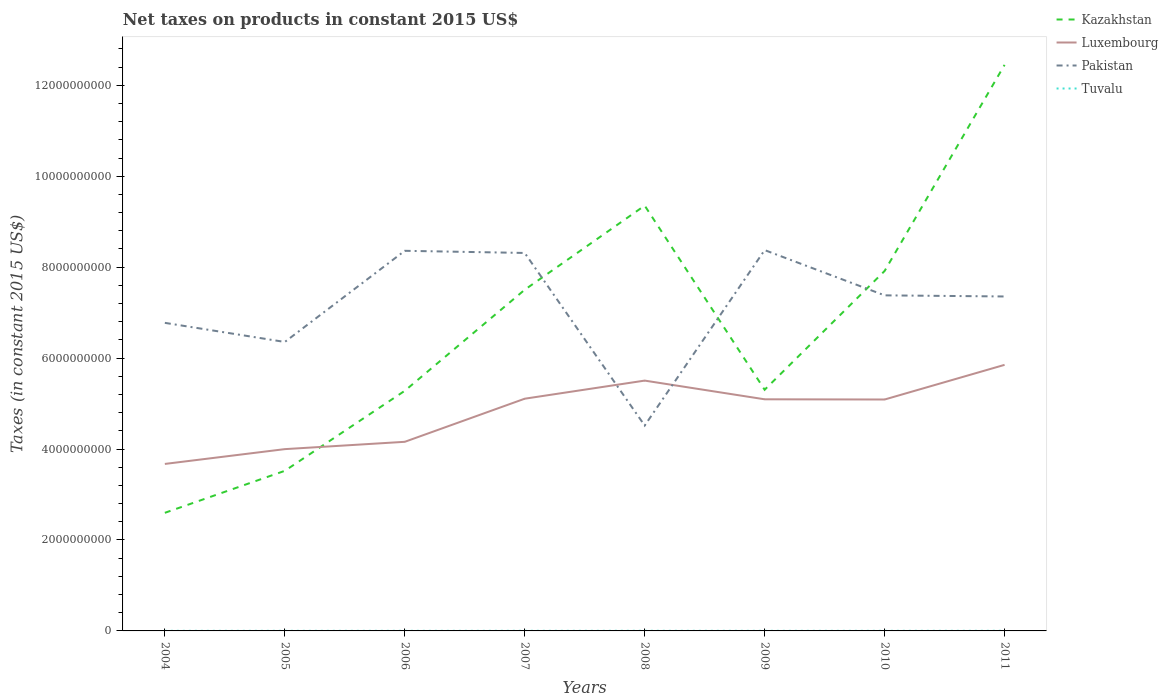Across all years, what is the maximum net taxes on products in Tuvalu?
Give a very brief answer. 1.97e+06. What is the total net taxes on products in Kazakhstan in the graph?
Offer a very short reply. -2.31e+07. What is the difference between the highest and the second highest net taxes on products in Kazakhstan?
Your answer should be very brief. 9.85e+09. What is the difference between the highest and the lowest net taxes on products in Kazakhstan?
Offer a very short reply. 4. What is the difference between two consecutive major ticks on the Y-axis?
Offer a very short reply. 2.00e+09. Does the graph contain any zero values?
Your answer should be compact. No. Does the graph contain grids?
Make the answer very short. No. Where does the legend appear in the graph?
Make the answer very short. Top right. How many legend labels are there?
Give a very brief answer. 4. What is the title of the graph?
Offer a very short reply. Net taxes on products in constant 2015 US$. What is the label or title of the Y-axis?
Your response must be concise. Taxes (in constant 2015 US$). What is the Taxes (in constant 2015 US$) of Kazakhstan in 2004?
Offer a very short reply. 2.60e+09. What is the Taxes (in constant 2015 US$) in Luxembourg in 2004?
Your answer should be very brief. 3.67e+09. What is the Taxes (in constant 2015 US$) of Pakistan in 2004?
Provide a succinct answer. 6.78e+09. What is the Taxes (in constant 2015 US$) in Tuvalu in 2004?
Ensure brevity in your answer.  2.11e+06. What is the Taxes (in constant 2015 US$) of Kazakhstan in 2005?
Keep it short and to the point. 3.52e+09. What is the Taxes (in constant 2015 US$) of Luxembourg in 2005?
Your answer should be compact. 4.00e+09. What is the Taxes (in constant 2015 US$) of Pakistan in 2005?
Make the answer very short. 6.35e+09. What is the Taxes (in constant 2015 US$) in Tuvalu in 2005?
Offer a very short reply. 2.13e+06. What is the Taxes (in constant 2015 US$) of Kazakhstan in 2006?
Keep it short and to the point. 5.28e+09. What is the Taxes (in constant 2015 US$) in Luxembourg in 2006?
Ensure brevity in your answer.  4.16e+09. What is the Taxes (in constant 2015 US$) in Pakistan in 2006?
Give a very brief answer. 8.36e+09. What is the Taxes (in constant 2015 US$) of Tuvalu in 2006?
Provide a short and direct response. 1.97e+06. What is the Taxes (in constant 2015 US$) in Kazakhstan in 2007?
Give a very brief answer. 7.50e+09. What is the Taxes (in constant 2015 US$) of Luxembourg in 2007?
Your answer should be compact. 5.11e+09. What is the Taxes (in constant 2015 US$) in Pakistan in 2007?
Your answer should be compact. 8.31e+09. What is the Taxes (in constant 2015 US$) of Tuvalu in 2007?
Offer a terse response. 2.33e+06. What is the Taxes (in constant 2015 US$) of Kazakhstan in 2008?
Your answer should be very brief. 9.35e+09. What is the Taxes (in constant 2015 US$) of Luxembourg in 2008?
Ensure brevity in your answer.  5.51e+09. What is the Taxes (in constant 2015 US$) in Pakistan in 2008?
Ensure brevity in your answer.  4.52e+09. What is the Taxes (in constant 2015 US$) in Tuvalu in 2008?
Offer a very short reply. 2.66e+06. What is the Taxes (in constant 2015 US$) of Kazakhstan in 2009?
Keep it short and to the point. 5.30e+09. What is the Taxes (in constant 2015 US$) in Luxembourg in 2009?
Your answer should be very brief. 5.09e+09. What is the Taxes (in constant 2015 US$) in Pakistan in 2009?
Provide a succinct answer. 8.38e+09. What is the Taxes (in constant 2015 US$) of Tuvalu in 2009?
Offer a very short reply. 2.12e+06. What is the Taxes (in constant 2015 US$) of Kazakhstan in 2010?
Your answer should be very brief. 7.92e+09. What is the Taxes (in constant 2015 US$) in Luxembourg in 2010?
Make the answer very short. 5.09e+09. What is the Taxes (in constant 2015 US$) of Pakistan in 2010?
Your answer should be compact. 7.38e+09. What is the Taxes (in constant 2015 US$) of Tuvalu in 2010?
Your answer should be very brief. 2.17e+06. What is the Taxes (in constant 2015 US$) in Kazakhstan in 2011?
Your response must be concise. 1.24e+1. What is the Taxes (in constant 2015 US$) in Luxembourg in 2011?
Your response must be concise. 5.85e+09. What is the Taxes (in constant 2015 US$) of Pakistan in 2011?
Your response must be concise. 7.36e+09. What is the Taxes (in constant 2015 US$) of Tuvalu in 2011?
Your answer should be very brief. 2.62e+06. Across all years, what is the maximum Taxes (in constant 2015 US$) in Kazakhstan?
Your response must be concise. 1.24e+1. Across all years, what is the maximum Taxes (in constant 2015 US$) of Luxembourg?
Your answer should be compact. 5.85e+09. Across all years, what is the maximum Taxes (in constant 2015 US$) in Pakistan?
Provide a succinct answer. 8.38e+09. Across all years, what is the maximum Taxes (in constant 2015 US$) in Tuvalu?
Offer a terse response. 2.66e+06. Across all years, what is the minimum Taxes (in constant 2015 US$) of Kazakhstan?
Make the answer very short. 2.60e+09. Across all years, what is the minimum Taxes (in constant 2015 US$) of Luxembourg?
Your answer should be compact. 3.67e+09. Across all years, what is the minimum Taxes (in constant 2015 US$) of Pakistan?
Provide a short and direct response. 4.52e+09. Across all years, what is the minimum Taxes (in constant 2015 US$) of Tuvalu?
Your response must be concise. 1.97e+06. What is the total Taxes (in constant 2015 US$) in Kazakhstan in the graph?
Keep it short and to the point. 5.39e+1. What is the total Taxes (in constant 2015 US$) of Luxembourg in the graph?
Keep it short and to the point. 3.85e+1. What is the total Taxes (in constant 2015 US$) in Pakistan in the graph?
Offer a very short reply. 5.74e+1. What is the total Taxes (in constant 2015 US$) of Tuvalu in the graph?
Provide a succinct answer. 1.81e+07. What is the difference between the Taxes (in constant 2015 US$) of Kazakhstan in 2004 and that in 2005?
Offer a very short reply. -9.24e+08. What is the difference between the Taxes (in constant 2015 US$) in Luxembourg in 2004 and that in 2005?
Your response must be concise. -3.26e+08. What is the difference between the Taxes (in constant 2015 US$) of Pakistan in 2004 and that in 2005?
Offer a terse response. 4.20e+08. What is the difference between the Taxes (in constant 2015 US$) of Tuvalu in 2004 and that in 2005?
Your response must be concise. -1.47e+04. What is the difference between the Taxes (in constant 2015 US$) of Kazakhstan in 2004 and that in 2006?
Ensure brevity in your answer.  -2.68e+09. What is the difference between the Taxes (in constant 2015 US$) in Luxembourg in 2004 and that in 2006?
Ensure brevity in your answer.  -4.86e+08. What is the difference between the Taxes (in constant 2015 US$) in Pakistan in 2004 and that in 2006?
Provide a succinct answer. -1.58e+09. What is the difference between the Taxes (in constant 2015 US$) of Tuvalu in 2004 and that in 2006?
Give a very brief answer. 1.41e+05. What is the difference between the Taxes (in constant 2015 US$) of Kazakhstan in 2004 and that in 2007?
Offer a very short reply. -4.91e+09. What is the difference between the Taxes (in constant 2015 US$) in Luxembourg in 2004 and that in 2007?
Keep it short and to the point. -1.43e+09. What is the difference between the Taxes (in constant 2015 US$) of Pakistan in 2004 and that in 2007?
Offer a terse response. -1.54e+09. What is the difference between the Taxes (in constant 2015 US$) in Tuvalu in 2004 and that in 2007?
Provide a succinct answer. -2.15e+05. What is the difference between the Taxes (in constant 2015 US$) of Kazakhstan in 2004 and that in 2008?
Provide a short and direct response. -6.76e+09. What is the difference between the Taxes (in constant 2015 US$) in Luxembourg in 2004 and that in 2008?
Provide a short and direct response. -1.83e+09. What is the difference between the Taxes (in constant 2015 US$) in Pakistan in 2004 and that in 2008?
Your response must be concise. 2.26e+09. What is the difference between the Taxes (in constant 2015 US$) of Tuvalu in 2004 and that in 2008?
Your response must be concise. -5.41e+05. What is the difference between the Taxes (in constant 2015 US$) of Kazakhstan in 2004 and that in 2009?
Make the answer very short. -2.71e+09. What is the difference between the Taxes (in constant 2015 US$) in Luxembourg in 2004 and that in 2009?
Ensure brevity in your answer.  -1.42e+09. What is the difference between the Taxes (in constant 2015 US$) in Pakistan in 2004 and that in 2009?
Ensure brevity in your answer.  -1.60e+09. What is the difference between the Taxes (in constant 2015 US$) in Tuvalu in 2004 and that in 2009?
Offer a very short reply. -3246.09. What is the difference between the Taxes (in constant 2015 US$) in Kazakhstan in 2004 and that in 2010?
Ensure brevity in your answer.  -5.32e+09. What is the difference between the Taxes (in constant 2015 US$) of Luxembourg in 2004 and that in 2010?
Offer a terse response. -1.42e+09. What is the difference between the Taxes (in constant 2015 US$) of Pakistan in 2004 and that in 2010?
Your answer should be compact. -6.05e+08. What is the difference between the Taxes (in constant 2015 US$) of Tuvalu in 2004 and that in 2010?
Provide a succinct answer. -5.14e+04. What is the difference between the Taxes (in constant 2015 US$) of Kazakhstan in 2004 and that in 2011?
Ensure brevity in your answer.  -9.85e+09. What is the difference between the Taxes (in constant 2015 US$) in Luxembourg in 2004 and that in 2011?
Your response must be concise. -2.18e+09. What is the difference between the Taxes (in constant 2015 US$) of Pakistan in 2004 and that in 2011?
Provide a succinct answer. -5.80e+08. What is the difference between the Taxes (in constant 2015 US$) in Tuvalu in 2004 and that in 2011?
Your answer should be very brief. -5.08e+05. What is the difference between the Taxes (in constant 2015 US$) in Kazakhstan in 2005 and that in 2006?
Give a very brief answer. -1.76e+09. What is the difference between the Taxes (in constant 2015 US$) in Luxembourg in 2005 and that in 2006?
Give a very brief answer. -1.61e+08. What is the difference between the Taxes (in constant 2015 US$) of Pakistan in 2005 and that in 2006?
Offer a very short reply. -2.00e+09. What is the difference between the Taxes (in constant 2015 US$) of Tuvalu in 2005 and that in 2006?
Give a very brief answer. 1.56e+05. What is the difference between the Taxes (in constant 2015 US$) in Kazakhstan in 2005 and that in 2007?
Offer a terse response. -3.98e+09. What is the difference between the Taxes (in constant 2015 US$) of Luxembourg in 2005 and that in 2007?
Provide a short and direct response. -1.11e+09. What is the difference between the Taxes (in constant 2015 US$) in Pakistan in 2005 and that in 2007?
Provide a succinct answer. -1.96e+09. What is the difference between the Taxes (in constant 2015 US$) in Tuvalu in 2005 and that in 2007?
Your answer should be very brief. -2.01e+05. What is the difference between the Taxes (in constant 2015 US$) in Kazakhstan in 2005 and that in 2008?
Keep it short and to the point. -5.83e+09. What is the difference between the Taxes (in constant 2015 US$) of Luxembourg in 2005 and that in 2008?
Offer a very short reply. -1.51e+09. What is the difference between the Taxes (in constant 2015 US$) in Pakistan in 2005 and that in 2008?
Your answer should be compact. 1.84e+09. What is the difference between the Taxes (in constant 2015 US$) of Tuvalu in 2005 and that in 2008?
Make the answer very short. -5.27e+05. What is the difference between the Taxes (in constant 2015 US$) in Kazakhstan in 2005 and that in 2009?
Provide a succinct answer. -1.78e+09. What is the difference between the Taxes (in constant 2015 US$) of Luxembourg in 2005 and that in 2009?
Offer a very short reply. -1.10e+09. What is the difference between the Taxes (in constant 2015 US$) of Pakistan in 2005 and that in 2009?
Provide a short and direct response. -2.02e+09. What is the difference between the Taxes (in constant 2015 US$) of Tuvalu in 2005 and that in 2009?
Your answer should be very brief. 1.15e+04. What is the difference between the Taxes (in constant 2015 US$) in Kazakhstan in 2005 and that in 2010?
Offer a terse response. -4.40e+09. What is the difference between the Taxes (in constant 2015 US$) in Luxembourg in 2005 and that in 2010?
Your answer should be very brief. -1.09e+09. What is the difference between the Taxes (in constant 2015 US$) in Pakistan in 2005 and that in 2010?
Ensure brevity in your answer.  -1.02e+09. What is the difference between the Taxes (in constant 2015 US$) in Tuvalu in 2005 and that in 2010?
Provide a short and direct response. -3.67e+04. What is the difference between the Taxes (in constant 2015 US$) of Kazakhstan in 2005 and that in 2011?
Keep it short and to the point. -8.93e+09. What is the difference between the Taxes (in constant 2015 US$) in Luxembourg in 2005 and that in 2011?
Provide a succinct answer. -1.85e+09. What is the difference between the Taxes (in constant 2015 US$) of Pakistan in 2005 and that in 2011?
Ensure brevity in your answer.  -1.00e+09. What is the difference between the Taxes (in constant 2015 US$) of Tuvalu in 2005 and that in 2011?
Your response must be concise. -4.93e+05. What is the difference between the Taxes (in constant 2015 US$) of Kazakhstan in 2006 and that in 2007?
Give a very brief answer. -2.22e+09. What is the difference between the Taxes (in constant 2015 US$) in Luxembourg in 2006 and that in 2007?
Give a very brief answer. -9.48e+08. What is the difference between the Taxes (in constant 2015 US$) of Pakistan in 2006 and that in 2007?
Your answer should be compact. 4.72e+07. What is the difference between the Taxes (in constant 2015 US$) in Tuvalu in 2006 and that in 2007?
Your answer should be compact. -3.57e+05. What is the difference between the Taxes (in constant 2015 US$) in Kazakhstan in 2006 and that in 2008?
Provide a short and direct response. -4.07e+09. What is the difference between the Taxes (in constant 2015 US$) of Luxembourg in 2006 and that in 2008?
Your answer should be very brief. -1.35e+09. What is the difference between the Taxes (in constant 2015 US$) of Pakistan in 2006 and that in 2008?
Offer a very short reply. 3.84e+09. What is the difference between the Taxes (in constant 2015 US$) in Tuvalu in 2006 and that in 2008?
Make the answer very short. -6.83e+05. What is the difference between the Taxes (in constant 2015 US$) in Kazakhstan in 2006 and that in 2009?
Ensure brevity in your answer.  -2.31e+07. What is the difference between the Taxes (in constant 2015 US$) of Luxembourg in 2006 and that in 2009?
Provide a short and direct response. -9.35e+08. What is the difference between the Taxes (in constant 2015 US$) in Pakistan in 2006 and that in 2009?
Your answer should be very brief. -1.55e+07. What is the difference between the Taxes (in constant 2015 US$) in Tuvalu in 2006 and that in 2009?
Provide a succinct answer. -1.45e+05. What is the difference between the Taxes (in constant 2015 US$) in Kazakhstan in 2006 and that in 2010?
Keep it short and to the point. -2.64e+09. What is the difference between the Taxes (in constant 2015 US$) of Luxembourg in 2006 and that in 2010?
Offer a terse response. -9.30e+08. What is the difference between the Taxes (in constant 2015 US$) of Pakistan in 2006 and that in 2010?
Keep it short and to the point. 9.80e+08. What is the difference between the Taxes (in constant 2015 US$) of Tuvalu in 2006 and that in 2010?
Your answer should be very brief. -1.93e+05. What is the difference between the Taxes (in constant 2015 US$) of Kazakhstan in 2006 and that in 2011?
Your response must be concise. -7.17e+09. What is the difference between the Taxes (in constant 2015 US$) in Luxembourg in 2006 and that in 2011?
Offer a terse response. -1.69e+09. What is the difference between the Taxes (in constant 2015 US$) in Pakistan in 2006 and that in 2011?
Provide a succinct answer. 1.00e+09. What is the difference between the Taxes (in constant 2015 US$) of Tuvalu in 2006 and that in 2011?
Your response must be concise. -6.49e+05. What is the difference between the Taxes (in constant 2015 US$) in Kazakhstan in 2007 and that in 2008?
Your answer should be very brief. -1.85e+09. What is the difference between the Taxes (in constant 2015 US$) in Luxembourg in 2007 and that in 2008?
Offer a very short reply. -3.98e+08. What is the difference between the Taxes (in constant 2015 US$) of Pakistan in 2007 and that in 2008?
Give a very brief answer. 3.80e+09. What is the difference between the Taxes (in constant 2015 US$) in Tuvalu in 2007 and that in 2008?
Give a very brief answer. -3.26e+05. What is the difference between the Taxes (in constant 2015 US$) of Kazakhstan in 2007 and that in 2009?
Ensure brevity in your answer.  2.20e+09. What is the difference between the Taxes (in constant 2015 US$) in Luxembourg in 2007 and that in 2009?
Your answer should be compact. 1.31e+07. What is the difference between the Taxes (in constant 2015 US$) in Pakistan in 2007 and that in 2009?
Provide a succinct answer. -6.28e+07. What is the difference between the Taxes (in constant 2015 US$) of Tuvalu in 2007 and that in 2009?
Provide a succinct answer. 2.12e+05. What is the difference between the Taxes (in constant 2015 US$) in Kazakhstan in 2007 and that in 2010?
Give a very brief answer. -4.13e+08. What is the difference between the Taxes (in constant 2015 US$) of Luxembourg in 2007 and that in 2010?
Give a very brief answer. 1.76e+07. What is the difference between the Taxes (in constant 2015 US$) in Pakistan in 2007 and that in 2010?
Provide a succinct answer. 9.33e+08. What is the difference between the Taxes (in constant 2015 US$) of Tuvalu in 2007 and that in 2010?
Your answer should be compact. 1.64e+05. What is the difference between the Taxes (in constant 2015 US$) in Kazakhstan in 2007 and that in 2011?
Your answer should be compact. -4.95e+09. What is the difference between the Taxes (in constant 2015 US$) in Luxembourg in 2007 and that in 2011?
Ensure brevity in your answer.  -7.44e+08. What is the difference between the Taxes (in constant 2015 US$) in Pakistan in 2007 and that in 2011?
Your answer should be very brief. 9.57e+08. What is the difference between the Taxes (in constant 2015 US$) in Tuvalu in 2007 and that in 2011?
Your answer should be compact. -2.92e+05. What is the difference between the Taxes (in constant 2015 US$) in Kazakhstan in 2008 and that in 2009?
Ensure brevity in your answer.  4.05e+09. What is the difference between the Taxes (in constant 2015 US$) of Luxembourg in 2008 and that in 2009?
Offer a terse response. 4.11e+08. What is the difference between the Taxes (in constant 2015 US$) in Pakistan in 2008 and that in 2009?
Offer a very short reply. -3.86e+09. What is the difference between the Taxes (in constant 2015 US$) in Tuvalu in 2008 and that in 2009?
Provide a short and direct response. 5.38e+05. What is the difference between the Taxes (in constant 2015 US$) of Kazakhstan in 2008 and that in 2010?
Your answer should be very brief. 1.44e+09. What is the difference between the Taxes (in constant 2015 US$) of Luxembourg in 2008 and that in 2010?
Provide a short and direct response. 4.16e+08. What is the difference between the Taxes (in constant 2015 US$) of Pakistan in 2008 and that in 2010?
Offer a very short reply. -2.86e+09. What is the difference between the Taxes (in constant 2015 US$) of Tuvalu in 2008 and that in 2010?
Ensure brevity in your answer.  4.90e+05. What is the difference between the Taxes (in constant 2015 US$) of Kazakhstan in 2008 and that in 2011?
Make the answer very short. -3.09e+09. What is the difference between the Taxes (in constant 2015 US$) in Luxembourg in 2008 and that in 2011?
Your response must be concise. -3.46e+08. What is the difference between the Taxes (in constant 2015 US$) of Pakistan in 2008 and that in 2011?
Your answer should be very brief. -2.84e+09. What is the difference between the Taxes (in constant 2015 US$) in Tuvalu in 2008 and that in 2011?
Provide a short and direct response. 3.36e+04. What is the difference between the Taxes (in constant 2015 US$) in Kazakhstan in 2009 and that in 2010?
Keep it short and to the point. -2.61e+09. What is the difference between the Taxes (in constant 2015 US$) in Luxembourg in 2009 and that in 2010?
Provide a succinct answer. 4.51e+06. What is the difference between the Taxes (in constant 2015 US$) in Pakistan in 2009 and that in 2010?
Make the answer very short. 9.95e+08. What is the difference between the Taxes (in constant 2015 US$) of Tuvalu in 2009 and that in 2010?
Offer a very short reply. -4.82e+04. What is the difference between the Taxes (in constant 2015 US$) of Kazakhstan in 2009 and that in 2011?
Your answer should be compact. -7.15e+09. What is the difference between the Taxes (in constant 2015 US$) in Luxembourg in 2009 and that in 2011?
Offer a very short reply. -7.57e+08. What is the difference between the Taxes (in constant 2015 US$) of Pakistan in 2009 and that in 2011?
Make the answer very short. 1.02e+09. What is the difference between the Taxes (in constant 2015 US$) in Tuvalu in 2009 and that in 2011?
Your response must be concise. -5.05e+05. What is the difference between the Taxes (in constant 2015 US$) in Kazakhstan in 2010 and that in 2011?
Ensure brevity in your answer.  -4.53e+09. What is the difference between the Taxes (in constant 2015 US$) in Luxembourg in 2010 and that in 2011?
Offer a terse response. -7.62e+08. What is the difference between the Taxes (in constant 2015 US$) of Pakistan in 2010 and that in 2011?
Your answer should be very brief. 2.47e+07. What is the difference between the Taxes (in constant 2015 US$) of Tuvalu in 2010 and that in 2011?
Ensure brevity in your answer.  -4.56e+05. What is the difference between the Taxes (in constant 2015 US$) in Kazakhstan in 2004 and the Taxes (in constant 2015 US$) in Luxembourg in 2005?
Offer a terse response. -1.40e+09. What is the difference between the Taxes (in constant 2015 US$) of Kazakhstan in 2004 and the Taxes (in constant 2015 US$) of Pakistan in 2005?
Provide a short and direct response. -3.76e+09. What is the difference between the Taxes (in constant 2015 US$) of Kazakhstan in 2004 and the Taxes (in constant 2015 US$) of Tuvalu in 2005?
Keep it short and to the point. 2.60e+09. What is the difference between the Taxes (in constant 2015 US$) in Luxembourg in 2004 and the Taxes (in constant 2015 US$) in Pakistan in 2005?
Offer a very short reply. -2.68e+09. What is the difference between the Taxes (in constant 2015 US$) in Luxembourg in 2004 and the Taxes (in constant 2015 US$) in Tuvalu in 2005?
Your answer should be compact. 3.67e+09. What is the difference between the Taxes (in constant 2015 US$) in Pakistan in 2004 and the Taxes (in constant 2015 US$) in Tuvalu in 2005?
Give a very brief answer. 6.77e+09. What is the difference between the Taxes (in constant 2015 US$) of Kazakhstan in 2004 and the Taxes (in constant 2015 US$) of Luxembourg in 2006?
Your answer should be compact. -1.56e+09. What is the difference between the Taxes (in constant 2015 US$) of Kazakhstan in 2004 and the Taxes (in constant 2015 US$) of Pakistan in 2006?
Provide a short and direct response. -5.76e+09. What is the difference between the Taxes (in constant 2015 US$) in Kazakhstan in 2004 and the Taxes (in constant 2015 US$) in Tuvalu in 2006?
Provide a short and direct response. 2.60e+09. What is the difference between the Taxes (in constant 2015 US$) of Luxembourg in 2004 and the Taxes (in constant 2015 US$) of Pakistan in 2006?
Your answer should be compact. -4.69e+09. What is the difference between the Taxes (in constant 2015 US$) of Luxembourg in 2004 and the Taxes (in constant 2015 US$) of Tuvalu in 2006?
Offer a very short reply. 3.67e+09. What is the difference between the Taxes (in constant 2015 US$) in Pakistan in 2004 and the Taxes (in constant 2015 US$) in Tuvalu in 2006?
Keep it short and to the point. 6.77e+09. What is the difference between the Taxes (in constant 2015 US$) of Kazakhstan in 2004 and the Taxes (in constant 2015 US$) of Luxembourg in 2007?
Keep it short and to the point. -2.51e+09. What is the difference between the Taxes (in constant 2015 US$) in Kazakhstan in 2004 and the Taxes (in constant 2015 US$) in Pakistan in 2007?
Ensure brevity in your answer.  -5.72e+09. What is the difference between the Taxes (in constant 2015 US$) in Kazakhstan in 2004 and the Taxes (in constant 2015 US$) in Tuvalu in 2007?
Make the answer very short. 2.59e+09. What is the difference between the Taxes (in constant 2015 US$) in Luxembourg in 2004 and the Taxes (in constant 2015 US$) in Pakistan in 2007?
Ensure brevity in your answer.  -4.64e+09. What is the difference between the Taxes (in constant 2015 US$) in Luxembourg in 2004 and the Taxes (in constant 2015 US$) in Tuvalu in 2007?
Your answer should be very brief. 3.67e+09. What is the difference between the Taxes (in constant 2015 US$) in Pakistan in 2004 and the Taxes (in constant 2015 US$) in Tuvalu in 2007?
Make the answer very short. 6.77e+09. What is the difference between the Taxes (in constant 2015 US$) of Kazakhstan in 2004 and the Taxes (in constant 2015 US$) of Luxembourg in 2008?
Provide a succinct answer. -2.91e+09. What is the difference between the Taxes (in constant 2015 US$) of Kazakhstan in 2004 and the Taxes (in constant 2015 US$) of Pakistan in 2008?
Offer a terse response. -1.92e+09. What is the difference between the Taxes (in constant 2015 US$) in Kazakhstan in 2004 and the Taxes (in constant 2015 US$) in Tuvalu in 2008?
Ensure brevity in your answer.  2.59e+09. What is the difference between the Taxes (in constant 2015 US$) in Luxembourg in 2004 and the Taxes (in constant 2015 US$) in Pakistan in 2008?
Keep it short and to the point. -8.44e+08. What is the difference between the Taxes (in constant 2015 US$) in Luxembourg in 2004 and the Taxes (in constant 2015 US$) in Tuvalu in 2008?
Give a very brief answer. 3.67e+09. What is the difference between the Taxes (in constant 2015 US$) in Pakistan in 2004 and the Taxes (in constant 2015 US$) in Tuvalu in 2008?
Give a very brief answer. 6.77e+09. What is the difference between the Taxes (in constant 2015 US$) in Kazakhstan in 2004 and the Taxes (in constant 2015 US$) in Luxembourg in 2009?
Ensure brevity in your answer.  -2.50e+09. What is the difference between the Taxes (in constant 2015 US$) of Kazakhstan in 2004 and the Taxes (in constant 2015 US$) of Pakistan in 2009?
Your answer should be compact. -5.78e+09. What is the difference between the Taxes (in constant 2015 US$) of Kazakhstan in 2004 and the Taxes (in constant 2015 US$) of Tuvalu in 2009?
Your answer should be very brief. 2.60e+09. What is the difference between the Taxes (in constant 2015 US$) of Luxembourg in 2004 and the Taxes (in constant 2015 US$) of Pakistan in 2009?
Your answer should be very brief. -4.70e+09. What is the difference between the Taxes (in constant 2015 US$) in Luxembourg in 2004 and the Taxes (in constant 2015 US$) in Tuvalu in 2009?
Ensure brevity in your answer.  3.67e+09. What is the difference between the Taxes (in constant 2015 US$) of Pakistan in 2004 and the Taxes (in constant 2015 US$) of Tuvalu in 2009?
Offer a terse response. 6.77e+09. What is the difference between the Taxes (in constant 2015 US$) in Kazakhstan in 2004 and the Taxes (in constant 2015 US$) in Luxembourg in 2010?
Your answer should be very brief. -2.49e+09. What is the difference between the Taxes (in constant 2015 US$) of Kazakhstan in 2004 and the Taxes (in constant 2015 US$) of Pakistan in 2010?
Give a very brief answer. -4.78e+09. What is the difference between the Taxes (in constant 2015 US$) of Kazakhstan in 2004 and the Taxes (in constant 2015 US$) of Tuvalu in 2010?
Provide a succinct answer. 2.60e+09. What is the difference between the Taxes (in constant 2015 US$) in Luxembourg in 2004 and the Taxes (in constant 2015 US$) in Pakistan in 2010?
Keep it short and to the point. -3.71e+09. What is the difference between the Taxes (in constant 2015 US$) of Luxembourg in 2004 and the Taxes (in constant 2015 US$) of Tuvalu in 2010?
Provide a short and direct response. 3.67e+09. What is the difference between the Taxes (in constant 2015 US$) of Pakistan in 2004 and the Taxes (in constant 2015 US$) of Tuvalu in 2010?
Ensure brevity in your answer.  6.77e+09. What is the difference between the Taxes (in constant 2015 US$) of Kazakhstan in 2004 and the Taxes (in constant 2015 US$) of Luxembourg in 2011?
Provide a succinct answer. -3.25e+09. What is the difference between the Taxes (in constant 2015 US$) in Kazakhstan in 2004 and the Taxes (in constant 2015 US$) in Pakistan in 2011?
Ensure brevity in your answer.  -4.76e+09. What is the difference between the Taxes (in constant 2015 US$) in Kazakhstan in 2004 and the Taxes (in constant 2015 US$) in Tuvalu in 2011?
Your answer should be very brief. 2.59e+09. What is the difference between the Taxes (in constant 2015 US$) in Luxembourg in 2004 and the Taxes (in constant 2015 US$) in Pakistan in 2011?
Your answer should be compact. -3.68e+09. What is the difference between the Taxes (in constant 2015 US$) in Luxembourg in 2004 and the Taxes (in constant 2015 US$) in Tuvalu in 2011?
Give a very brief answer. 3.67e+09. What is the difference between the Taxes (in constant 2015 US$) in Pakistan in 2004 and the Taxes (in constant 2015 US$) in Tuvalu in 2011?
Keep it short and to the point. 6.77e+09. What is the difference between the Taxes (in constant 2015 US$) of Kazakhstan in 2005 and the Taxes (in constant 2015 US$) of Luxembourg in 2006?
Your answer should be very brief. -6.38e+08. What is the difference between the Taxes (in constant 2015 US$) in Kazakhstan in 2005 and the Taxes (in constant 2015 US$) in Pakistan in 2006?
Make the answer very short. -4.84e+09. What is the difference between the Taxes (in constant 2015 US$) in Kazakhstan in 2005 and the Taxes (in constant 2015 US$) in Tuvalu in 2006?
Make the answer very short. 3.52e+09. What is the difference between the Taxes (in constant 2015 US$) of Luxembourg in 2005 and the Taxes (in constant 2015 US$) of Pakistan in 2006?
Provide a succinct answer. -4.36e+09. What is the difference between the Taxes (in constant 2015 US$) in Luxembourg in 2005 and the Taxes (in constant 2015 US$) in Tuvalu in 2006?
Provide a short and direct response. 4.00e+09. What is the difference between the Taxes (in constant 2015 US$) in Pakistan in 2005 and the Taxes (in constant 2015 US$) in Tuvalu in 2006?
Provide a succinct answer. 6.35e+09. What is the difference between the Taxes (in constant 2015 US$) in Kazakhstan in 2005 and the Taxes (in constant 2015 US$) in Luxembourg in 2007?
Provide a succinct answer. -1.59e+09. What is the difference between the Taxes (in constant 2015 US$) of Kazakhstan in 2005 and the Taxes (in constant 2015 US$) of Pakistan in 2007?
Keep it short and to the point. -4.79e+09. What is the difference between the Taxes (in constant 2015 US$) of Kazakhstan in 2005 and the Taxes (in constant 2015 US$) of Tuvalu in 2007?
Provide a succinct answer. 3.52e+09. What is the difference between the Taxes (in constant 2015 US$) in Luxembourg in 2005 and the Taxes (in constant 2015 US$) in Pakistan in 2007?
Provide a short and direct response. -4.31e+09. What is the difference between the Taxes (in constant 2015 US$) of Luxembourg in 2005 and the Taxes (in constant 2015 US$) of Tuvalu in 2007?
Your answer should be very brief. 4.00e+09. What is the difference between the Taxes (in constant 2015 US$) of Pakistan in 2005 and the Taxes (in constant 2015 US$) of Tuvalu in 2007?
Your answer should be very brief. 6.35e+09. What is the difference between the Taxes (in constant 2015 US$) in Kazakhstan in 2005 and the Taxes (in constant 2015 US$) in Luxembourg in 2008?
Offer a very short reply. -1.98e+09. What is the difference between the Taxes (in constant 2015 US$) of Kazakhstan in 2005 and the Taxes (in constant 2015 US$) of Pakistan in 2008?
Your response must be concise. -9.96e+08. What is the difference between the Taxes (in constant 2015 US$) in Kazakhstan in 2005 and the Taxes (in constant 2015 US$) in Tuvalu in 2008?
Your answer should be very brief. 3.52e+09. What is the difference between the Taxes (in constant 2015 US$) of Luxembourg in 2005 and the Taxes (in constant 2015 US$) of Pakistan in 2008?
Offer a terse response. -5.19e+08. What is the difference between the Taxes (in constant 2015 US$) of Luxembourg in 2005 and the Taxes (in constant 2015 US$) of Tuvalu in 2008?
Provide a short and direct response. 4.00e+09. What is the difference between the Taxes (in constant 2015 US$) in Pakistan in 2005 and the Taxes (in constant 2015 US$) in Tuvalu in 2008?
Make the answer very short. 6.35e+09. What is the difference between the Taxes (in constant 2015 US$) in Kazakhstan in 2005 and the Taxes (in constant 2015 US$) in Luxembourg in 2009?
Give a very brief answer. -1.57e+09. What is the difference between the Taxes (in constant 2015 US$) of Kazakhstan in 2005 and the Taxes (in constant 2015 US$) of Pakistan in 2009?
Keep it short and to the point. -4.85e+09. What is the difference between the Taxes (in constant 2015 US$) in Kazakhstan in 2005 and the Taxes (in constant 2015 US$) in Tuvalu in 2009?
Ensure brevity in your answer.  3.52e+09. What is the difference between the Taxes (in constant 2015 US$) of Luxembourg in 2005 and the Taxes (in constant 2015 US$) of Pakistan in 2009?
Ensure brevity in your answer.  -4.38e+09. What is the difference between the Taxes (in constant 2015 US$) in Luxembourg in 2005 and the Taxes (in constant 2015 US$) in Tuvalu in 2009?
Offer a very short reply. 4.00e+09. What is the difference between the Taxes (in constant 2015 US$) in Pakistan in 2005 and the Taxes (in constant 2015 US$) in Tuvalu in 2009?
Your answer should be very brief. 6.35e+09. What is the difference between the Taxes (in constant 2015 US$) of Kazakhstan in 2005 and the Taxes (in constant 2015 US$) of Luxembourg in 2010?
Ensure brevity in your answer.  -1.57e+09. What is the difference between the Taxes (in constant 2015 US$) of Kazakhstan in 2005 and the Taxes (in constant 2015 US$) of Pakistan in 2010?
Provide a succinct answer. -3.86e+09. What is the difference between the Taxes (in constant 2015 US$) in Kazakhstan in 2005 and the Taxes (in constant 2015 US$) in Tuvalu in 2010?
Provide a short and direct response. 3.52e+09. What is the difference between the Taxes (in constant 2015 US$) in Luxembourg in 2005 and the Taxes (in constant 2015 US$) in Pakistan in 2010?
Offer a very short reply. -3.38e+09. What is the difference between the Taxes (in constant 2015 US$) of Luxembourg in 2005 and the Taxes (in constant 2015 US$) of Tuvalu in 2010?
Ensure brevity in your answer.  4.00e+09. What is the difference between the Taxes (in constant 2015 US$) in Pakistan in 2005 and the Taxes (in constant 2015 US$) in Tuvalu in 2010?
Provide a succinct answer. 6.35e+09. What is the difference between the Taxes (in constant 2015 US$) of Kazakhstan in 2005 and the Taxes (in constant 2015 US$) of Luxembourg in 2011?
Keep it short and to the point. -2.33e+09. What is the difference between the Taxes (in constant 2015 US$) of Kazakhstan in 2005 and the Taxes (in constant 2015 US$) of Pakistan in 2011?
Your response must be concise. -3.83e+09. What is the difference between the Taxes (in constant 2015 US$) of Kazakhstan in 2005 and the Taxes (in constant 2015 US$) of Tuvalu in 2011?
Give a very brief answer. 3.52e+09. What is the difference between the Taxes (in constant 2015 US$) in Luxembourg in 2005 and the Taxes (in constant 2015 US$) in Pakistan in 2011?
Your response must be concise. -3.36e+09. What is the difference between the Taxes (in constant 2015 US$) in Luxembourg in 2005 and the Taxes (in constant 2015 US$) in Tuvalu in 2011?
Offer a very short reply. 4.00e+09. What is the difference between the Taxes (in constant 2015 US$) of Pakistan in 2005 and the Taxes (in constant 2015 US$) of Tuvalu in 2011?
Provide a short and direct response. 6.35e+09. What is the difference between the Taxes (in constant 2015 US$) in Kazakhstan in 2006 and the Taxes (in constant 2015 US$) in Luxembourg in 2007?
Keep it short and to the point. 1.74e+08. What is the difference between the Taxes (in constant 2015 US$) of Kazakhstan in 2006 and the Taxes (in constant 2015 US$) of Pakistan in 2007?
Make the answer very short. -3.03e+09. What is the difference between the Taxes (in constant 2015 US$) of Kazakhstan in 2006 and the Taxes (in constant 2015 US$) of Tuvalu in 2007?
Offer a very short reply. 5.28e+09. What is the difference between the Taxes (in constant 2015 US$) of Luxembourg in 2006 and the Taxes (in constant 2015 US$) of Pakistan in 2007?
Give a very brief answer. -4.15e+09. What is the difference between the Taxes (in constant 2015 US$) of Luxembourg in 2006 and the Taxes (in constant 2015 US$) of Tuvalu in 2007?
Ensure brevity in your answer.  4.16e+09. What is the difference between the Taxes (in constant 2015 US$) in Pakistan in 2006 and the Taxes (in constant 2015 US$) in Tuvalu in 2007?
Provide a short and direct response. 8.36e+09. What is the difference between the Taxes (in constant 2015 US$) of Kazakhstan in 2006 and the Taxes (in constant 2015 US$) of Luxembourg in 2008?
Provide a succinct answer. -2.25e+08. What is the difference between the Taxes (in constant 2015 US$) in Kazakhstan in 2006 and the Taxes (in constant 2015 US$) in Pakistan in 2008?
Provide a short and direct response. 7.64e+08. What is the difference between the Taxes (in constant 2015 US$) in Kazakhstan in 2006 and the Taxes (in constant 2015 US$) in Tuvalu in 2008?
Ensure brevity in your answer.  5.28e+09. What is the difference between the Taxes (in constant 2015 US$) in Luxembourg in 2006 and the Taxes (in constant 2015 US$) in Pakistan in 2008?
Ensure brevity in your answer.  -3.58e+08. What is the difference between the Taxes (in constant 2015 US$) in Luxembourg in 2006 and the Taxes (in constant 2015 US$) in Tuvalu in 2008?
Make the answer very short. 4.16e+09. What is the difference between the Taxes (in constant 2015 US$) of Pakistan in 2006 and the Taxes (in constant 2015 US$) of Tuvalu in 2008?
Offer a very short reply. 8.36e+09. What is the difference between the Taxes (in constant 2015 US$) in Kazakhstan in 2006 and the Taxes (in constant 2015 US$) in Luxembourg in 2009?
Provide a succinct answer. 1.87e+08. What is the difference between the Taxes (in constant 2015 US$) in Kazakhstan in 2006 and the Taxes (in constant 2015 US$) in Pakistan in 2009?
Provide a succinct answer. -3.09e+09. What is the difference between the Taxes (in constant 2015 US$) of Kazakhstan in 2006 and the Taxes (in constant 2015 US$) of Tuvalu in 2009?
Offer a very short reply. 5.28e+09. What is the difference between the Taxes (in constant 2015 US$) of Luxembourg in 2006 and the Taxes (in constant 2015 US$) of Pakistan in 2009?
Offer a very short reply. -4.22e+09. What is the difference between the Taxes (in constant 2015 US$) in Luxembourg in 2006 and the Taxes (in constant 2015 US$) in Tuvalu in 2009?
Provide a succinct answer. 4.16e+09. What is the difference between the Taxes (in constant 2015 US$) of Pakistan in 2006 and the Taxes (in constant 2015 US$) of Tuvalu in 2009?
Keep it short and to the point. 8.36e+09. What is the difference between the Taxes (in constant 2015 US$) of Kazakhstan in 2006 and the Taxes (in constant 2015 US$) of Luxembourg in 2010?
Your response must be concise. 1.91e+08. What is the difference between the Taxes (in constant 2015 US$) in Kazakhstan in 2006 and the Taxes (in constant 2015 US$) in Pakistan in 2010?
Ensure brevity in your answer.  -2.10e+09. What is the difference between the Taxes (in constant 2015 US$) of Kazakhstan in 2006 and the Taxes (in constant 2015 US$) of Tuvalu in 2010?
Provide a short and direct response. 5.28e+09. What is the difference between the Taxes (in constant 2015 US$) in Luxembourg in 2006 and the Taxes (in constant 2015 US$) in Pakistan in 2010?
Ensure brevity in your answer.  -3.22e+09. What is the difference between the Taxes (in constant 2015 US$) of Luxembourg in 2006 and the Taxes (in constant 2015 US$) of Tuvalu in 2010?
Give a very brief answer. 4.16e+09. What is the difference between the Taxes (in constant 2015 US$) in Pakistan in 2006 and the Taxes (in constant 2015 US$) in Tuvalu in 2010?
Offer a very short reply. 8.36e+09. What is the difference between the Taxes (in constant 2015 US$) in Kazakhstan in 2006 and the Taxes (in constant 2015 US$) in Luxembourg in 2011?
Provide a succinct answer. -5.71e+08. What is the difference between the Taxes (in constant 2015 US$) of Kazakhstan in 2006 and the Taxes (in constant 2015 US$) of Pakistan in 2011?
Keep it short and to the point. -2.07e+09. What is the difference between the Taxes (in constant 2015 US$) of Kazakhstan in 2006 and the Taxes (in constant 2015 US$) of Tuvalu in 2011?
Keep it short and to the point. 5.28e+09. What is the difference between the Taxes (in constant 2015 US$) of Luxembourg in 2006 and the Taxes (in constant 2015 US$) of Pakistan in 2011?
Offer a terse response. -3.20e+09. What is the difference between the Taxes (in constant 2015 US$) of Luxembourg in 2006 and the Taxes (in constant 2015 US$) of Tuvalu in 2011?
Give a very brief answer. 4.16e+09. What is the difference between the Taxes (in constant 2015 US$) in Pakistan in 2006 and the Taxes (in constant 2015 US$) in Tuvalu in 2011?
Ensure brevity in your answer.  8.36e+09. What is the difference between the Taxes (in constant 2015 US$) of Kazakhstan in 2007 and the Taxes (in constant 2015 US$) of Luxembourg in 2008?
Provide a succinct answer. 2.00e+09. What is the difference between the Taxes (in constant 2015 US$) of Kazakhstan in 2007 and the Taxes (in constant 2015 US$) of Pakistan in 2008?
Provide a short and direct response. 2.99e+09. What is the difference between the Taxes (in constant 2015 US$) of Kazakhstan in 2007 and the Taxes (in constant 2015 US$) of Tuvalu in 2008?
Offer a terse response. 7.50e+09. What is the difference between the Taxes (in constant 2015 US$) in Luxembourg in 2007 and the Taxes (in constant 2015 US$) in Pakistan in 2008?
Your response must be concise. 5.90e+08. What is the difference between the Taxes (in constant 2015 US$) in Luxembourg in 2007 and the Taxes (in constant 2015 US$) in Tuvalu in 2008?
Provide a succinct answer. 5.10e+09. What is the difference between the Taxes (in constant 2015 US$) of Pakistan in 2007 and the Taxes (in constant 2015 US$) of Tuvalu in 2008?
Keep it short and to the point. 8.31e+09. What is the difference between the Taxes (in constant 2015 US$) of Kazakhstan in 2007 and the Taxes (in constant 2015 US$) of Luxembourg in 2009?
Your response must be concise. 2.41e+09. What is the difference between the Taxes (in constant 2015 US$) in Kazakhstan in 2007 and the Taxes (in constant 2015 US$) in Pakistan in 2009?
Offer a very short reply. -8.72e+08. What is the difference between the Taxes (in constant 2015 US$) in Kazakhstan in 2007 and the Taxes (in constant 2015 US$) in Tuvalu in 2009?
Offer a very short reply. 7.50e+09. What is the difference between the Taxes (in constant 2015 US$) in Luxembourg in 2007 and the Taxes (in constant 2015 US$) in Pakistan in 2009?
Make the answer very short. -3.27e+09. What is the difference between the Taxes (in constant 2015 US$) in Luxembourg in 2007 and the Taxes (in constant 2015 US$) in Tuvalu in 2009?
Ensure brevity in your answer.  5.10e+09. What is the difference between the Taxes (in constant 2015 US$) of Pakistan in 2007 and the Taxes (in constant 2015 US$) of Tuvalu in 2009?
Give a very brief answer. 8.31e+09. What is the difference between the Taxes (in constant 2015 US$) of Kazakhstan in 2007 and the Taxes (in constant 2015 US$) of Luxembourg in 2010?
Keep it short and to the point. 2.41e+09. What is the difference between the Taxes (in constant 2015 US$) in Kazakhstan in 2007 and the Taxes (in constant 2015 US$) in Pakistan in 2010?
Your answer should be very brief. 1.24e+08. What is the difference between the Taxes (in constant 2015 US$) in Kazakhstan in 2007 and the Taxes (in constant 2015 US$) in Tuvalu in 2010?
Offer a very short reply. 7.50e+09. What is the difference between the Taxes (in constant 2015 US$) of Luxembourg in 2007 and the Taxes (in constant 2015 US$) of Pakistan in 2010?
Offer a very short reply. -2.27e+09. What is the difference between the Taxes (in constant 2015 US$) of Luxembourg in 2007 and the Taxes (in constant 2015 US$) of Tuvalu in 2010?
Give a very brief answer. 5.10e+09. What is the difference between the Taxes (in constant 2015 US$) of Pakistan in 2007 and the Taxes (in constant 2015 US$) of Tuvalu in 2010?
Your answer should be compact. 8.31e+09. What is the difference between the Taxes (in constant 2015 US$) of Kazakhstan in 2007 and the Taxes (in constant 2015 US$) of Luxembourg in 2011?
Your answer should be compact. 1.65e+09. What is the difference between the Taxes (in constant 2015 US$) in Kazakhstan in 2007 and the Taxes (in constant 2015 US$) in Pakistan in 2011?
Give a very brief answer. 1.48e+08. What is the difference between the Taxes (in constant 2015 US$) in Kazakhstan in 2007 and the Taxes (in constant 2015 US$) in Tuvalu in 2011?
Ensure brevity in your answer.  7.50e+09. What is the difference between the Taxes (in constant 2015 US$) in Luxembourg in 2007 and the Taxes (in constant 2015 US$) in Pakistan in 2011?
Provide a short and direct response. -2.25e+09. What is the difference between the Taxes (in constant 2015 US$) in Luxembourg in 2007 and the Taxes (in constant 2015 US$) in Tuvalu in 2011?
Make the answer very short. 5.10e+09. What is the difference between the Taxes (in constant 2015 US$) of Pakistan in 2007 and the Taxes (in constant 2015 US$) of Tuvalu in 2011?
Offer a terse response. 8.31e+09. What is the difference between the Taxes (in constant 2015 US$) of Kazakhstan in 2008 and the Taxes (in constant 2015 US$) of Luxembourg in 2009?
Provide a short and direct response. 4.26e+09. What is the difference between the Taxes (in constant 2015 US$) of Kazakhstan in 2008 and the Taxes (in constant 2015 US$) of Pakistan in 2009?
Your answer should be very brief. 9.79e+08. What is the difference between the Taxes (in constant 2015 US$) of Kazakhstan in 2008 and the Taxes (in constant 2015 US$) of Tuvalu in 2009?
Keep it short and to the point. 9.35e+09. What is the difference between the Taxes (in constant 2015 US$) of Luxembourg in 2008 and the Taxes (in constant 2015 US$) of Pakistan in 2009?
Offer a very short reply. -2.87e+09. What is the difference between the Taxes (in constant 2015 US$) of Luxembourg in 2008 and the Taxes (in constant 2015 US$) of Tuvalu in 2009?
Your answer should be very brief. 5.50e+09. What is the difference between the Taxes (in constant 2015 US$) of Pakistan in 2008 and the Taxes (in constant 2015 US$) of Tuvalu in 2009?
Offer a very short reply. 4.51e+09. What is the difference between the Taxes (in constant 2015 US$) in Kazakhstan in 2008 and the Taxes (in constant 2015 US$) in Luxembourg in 2010?
Provide a succinct answer. 4.26e+09. What is the difference between the Taxes (in constant 2015 US$) in Kazakhstan in 2008 and the Taxes (in constant 2015 US$) in Pakistan in 2010?
Keep it short and to the point. 1.97e+09. What is the difference between the Taxes (in constant 2015 US$) in Kazakhstan in 2008 and the Taxes (in constant 2015 US$) in Tuvalu in 2010?
Keep it short and to the point. 9.35e+09. What is the difference between the Taxes (in constant 2015 US$) in Luxembourg in 2008 and the Taxes (in constant 2015 US$) in Pakistan in 2010?
Your response must be concise. -1.87e+09. What is the difference between the Taxes (in constant 2015 US$) in Luxembourg in 2008 and the Taxes (in constant 2015 US$) in Tuvalu in 2010?
Your answer should be compact. 5.50e+09. What is the difference between the Taxes (in constant 2015 US$) in Pakistan in 2008 and the Taxes (in constant 2015 US$) in Tuvalu in 2010?
Offer a very short reply. 4.51e+09. What is the difference between the Taxes (in constant 2015 US$) of Kazakhstan in 2008 and the Taxes (in constant 2015 US$) of Luxembourg in 2011?
Your answer should be compact. 3.50e+09. What is the difference between the Taxes (in constant 2015 US$) in Kazakhstan in 2008 and the Taxes (in constant 2015 US$) in Pakistan in 2011?
Give a very brief answer. 2.00e+09. What is the difference between the Taxes (in constant 2015 US$) of Kazakhstan in 2008 and the Taxes (in constant 2015 US$) of Tuvalu in 2011?
Your answer should be very brief. 9.35e+09. What is the difference between the Taxes (in constant 2015 US$) of Luxembourg in 2008 and the Taxes (in constant 2015 US$) of Pakistan in 2011?
Provide a succinct answer. -1.85e+09. What is the difference between the Taxes (in constant 2015 US$) in Luxembourg in 2008 and the Taxes (in constant 2015 US$) in Tuvalu in 2011?
Ensure brevity in your answer.  5.50e+09. What is the difference between the Taxes (in constant 2015 US$) of Pakistan in 2008 and the Taxes (in constant 2015 US$) of Tuvalu in 2011?
Your answer should be very brief. 4.51e+09. What is the difference between the Taxes (in constant 2015 US$) in Kazakhstan in 2009 and the Taxes (in constant 2015 US$) in Luxembourg in 2010?
Provide a short and direct response. 2.14e+08. What is the difference between the Taxes (in constant 2015 US$) in Kazakhstan in 2009 and the Taxes (in constant 2015 US$) in Pakistan in 2010?
Your response must be concise. -2.08e+09. What is the difference between the Taxes (in constant 2015 US$) in Kazakhstan in 2009 and the Taxes (in constant 2015 US$) in Tuvalu in 2010?
Give a very brief answer. 5.30e+09. What is the difference between the Taxes (in constant 2015 US$) in Luxembourg in 2009 and the Taxes (in constant 2015 US$) in Pakistan in 2010?
Your answer should be compact. -2.29e+09. What is the difference between the Taxes (in constant 2015 US$) in Luxembourg in 2009 and the Taxes (in constant 2015 US$) in Tuvalu in 2010?
Your answer should be very brief. 5.09e+09. What is the difference between the Taxes (in constant 2015 US$) of Pakistan in 2009 and the Taxes (in constant 2015 US$) of Tuvalu in 2010?
Your response must be concise. 8.37e+09. What is the difference between the Taxes (in constant 2015 US$) of Kazakhstan in 2009 and the Taxes (in constant 2015 US$) of Luxembourg in 2011?
Keep it short and to the point. -5.48e+08. What is the difference between the Taxes (in constant 2015 US$) of Kazakhstan in 2009 and the Taxes (in constant 2015 US$) of Pakistan in 2011?
Give a very brief answer. -2.05e+09. What is the difference between the Taxes (in constant 2015 US$) of Kazakhstan in 2009 and the Taxes (in constant 2015 US$) of Tuvalu in 2011?
Offer a very short reply. 5.30e+09. What is the difference between the Taxes (in constant 2015 US$) of Luxembourg in 2009 and the Taxes (in constant 2015 US$) of Pakistan in 2011?
Give a very brief answer. -2.26e+09. What is the difference between the Taxes (in constant 2015 US$) of Luxembourg in 2009 and the Taxes (in constant 2015 US$) of Tuvalu in 2011?
Provide a short and direct response. 5.09e+09. What is the difference between the Taxes (in constant 2015 US$) in Pakistan in 2009 and the Taxes (in constant 2015 US$) in Tuvalu in 2011?
Offer a terse response. 8.37e+09. What is the difference between the Taxes (in constant 2015 US$) of Kazakhstan in 2010 and the Taxes (in constant 2015 US$) of Luxembourg in 2011?
Offer a very short reply. 2.06e+09. What is the difference between the Taxes (in constant 2015 US$) of Kazakhstan in 2010 and the Taxes (in constant 2015 US$) of Pakistan in 2011?
Make the answer very short. 5.61e+08. What is the difference between the Taxes (in constant 2015 US$) in Kazakhstan in 2010 and the Taxes (in constant 2015 US$) in Tuvalu in 2011?
Give a very brief answer. 7.91e+09. What is the difference between the Taxes (in constant 2015 US$) in Luxembourg in 2010 and the Taxes (in constant 2015 US$) in Pakistan in 2011?
Keep it short and to the point. -2.27e+09. What is the difference between the Taxes (in constant 2015 US$) in Luxembourg in 2010 and the Taxes (in constant 2015 US$) in Tuvalu in 2011?
Give a very brief answer. 5.09e+09. What is the difference between the Taxes (in constant 2015 US$) in Pakistan in 2010 and the Taxes (in constant 2015 US$) in Tuvalu in 2011?
Keep it short and to the point. 7.38e+09. What is the average Taxes (in constant 2015 US$) of Kazakhstan per year?
Your response must be concise. 6.74e+09. What is the average Taxes (in constant 2015 US$) of Luxembourg per year?
Provide a short and direct response. 4.81e+09. What is the average Taxes (in constant 2015 US$) in Pakistan per year?
Give a very brief answer. 7.18e+09. What is the average Taxes (in constant 2015 US$) in Tuvalu per year?
Offer a terse response. 2.26e+06. In the year 2004, what is the difference between the Taxes (in constant 2015 US$) of Kazakhstan and Taxes (in constant 2015 US$) of Luxembourg?
Give a very brief answer. -1.08e+09. In the year 2004, what is the difference between the Taxes (in constant 2015 US$) in Kazakhstan and Taxes (in constant 2015 US$) in Pakistan?
Provide a short and direct response. -4.18e+09. In the year 2004, what is the difference between the Taxes (in constant 2015 US$) of Kazakhstan and Taxes (in constant 2015 US$) of Tuvalu?
Provide a succinct answer. 2.60e+09. In the year 2004, what is the difference between the Taxes (in constant 2015 US$) in Luxembourg and Taxes (in constant 2015 US$) in Pakistan?
Give a very brief answer. -3.10e+09. In the year 2004, what is the difference between the Taxes (in constant 2015 US$) in Luxembourg and Taxes (in constant 2015 US$) in Tuvalu?
Your answer should be very brief. 3.67e+09. In the year 2004, what is the difference between the Taxes (in constant 2015 US$) of Pakistan and Taxes (in constant 2015 US$) of Tuvalu?
Offer a terse response. 6.77e+09. In the year 2005, what is the difference between the Taxes (in constant 2015 US$) of Kazakhstan and Taxes (in constant 2015 US$) of Luxembourg?
Offer a terse response. -4.77e+08. In the year 2005, what is the difference between the Taxes (in constant 2015 US$) in Kazakhstan and Taxes (in constant 2015 US$) in Pakistan?
Provide a succinct answer. -2.83e+09. In the year 2005, what is the difference between the Taxes (in constant 2015 US$) of Kazakhstan and Taxes (in constant 2015 US$) of Tuvalu?
Give a very brief answer. 3.52e+09. In the year 2005, what is the difference between the Taxes (in constant 2015 US$) of Luxembourg and Taxes (in constant 2015 US$) of Pakistan?
Ensure brevity in your answer.  -2.36e+09. In the year 2005, what is the difference between the Taxes (in constant 2015 US$) of Luxembourg and Taxes (in constant 2015 US$) of Tuvalu?
Ensure brevity in your answer.  4.00e+09. In the year 2005, what is the difference between the Taxes (in constant 2015 US$) of Pakistan and Taxes (in constant 2015 US$) of Tuvalu?
Your answer should be compact. 6.35e+09. In the year 2006, what is the difference between the Taxes (in constant 2015 US$) of Kazakhstan and Taxes (in constant 2015 US$) of Luxembourg?
Make the answer very short. 1.12e+09. In the year 2006, what is the difference between the Taxes (in constant 2015 US$) of Kazakhstan and Taxes (in constant 2015 US$) of Pakistan?
Your response must be concise. -3.08e+09. In the year 2006, what is the difference between the Taxes (in constant 2015 US$) of Kazakhstan and Taxes (in constant 2015 US$) of Tuvalu?
Your answer should be compact. 5.28e+09. In the year 2006, what is the difference between the Taxes (in constant 2015 US$) in Luxembourg and Taxes (in constant 2015 US$) in Pakistan?
Make the answer very short. -4.20e+09. In the year 2006, what is the difference between the Taxes (in constant 2015 US$) of Luxembourg and Taxes (in constant 2015 US$) of Tuvalu?
Offer a terse response. 4.16e+09. In the year 2006, what is the difference between the Taxes (in constant 2015 US$) in Pakistan and Taxes (in constant 2015 US$) in Tuvalu?
Ensure brevity in your answer.  8.36e+09. In the year 2007, what is the difference between the Taxes (in constant 2015 US$) in Kazakhstan and Taxes (in constant 2015 US$) in Luxembourg?
Ensure brevity in your answer.  2.40e+09. In the year 2007, what is the difference between the Taxes (in constant 2015 US$) in Kazakhstan and Taxes (in constant 2015 US$) in Pakistan?
Provide a short and direct response. -8.09e+08. In the year 2007, what is the difference between the Taxes (in constant 2015 US$) of Kazakhstan and Taxes (in constant 2015 US$) of Tuvalu?
Provide a short and direct response. 7.50e+09. In the year 2007, what is the difference between the Taxes (in constant 2015 US$) in Luxembourg and Taxes (in constant 2015 US$) in Pakistan?
Make the answer very short. -3.21e+09. In the year 2007, what is the difference between the Taxes (in constant 2015 US$) in Luxembourg and Taxes (in constant 2015 US$) in Tuvalu?
Keep it short and to the point. 5.10e+09. In the year 2007, what is the difference between the Taxes (in constant 2015 US$) in Pakistan and Taxes (in constant 2015 US$) in Tuvalu?
Your answer should be compact. 8.31e+09. In the year 2008, what is the difference between the Taxes (in constant 2015 US$) in Kazakhstan and Taxes (in constant 2015 US$) in Luxembourg?
Your response must be concise. 3.85e+09. In the year 2008, what is the difference between the Taxes (in constant 2015 US$) of Kazakhstan and Taxes (in constant 2015 US$) of Pakistan?
Give a very brief answer. 4.84e+09. In the year 2008, what is the difference between the Taxes (in constant 2015 US$) of Kazakhstan and Taxes (in constant 2015 US$) of Tuvalu?
Make the answer very short. 9.35e+09. In the year 2008, what is the difference between the Taxes (in constant 2015 US$) of Luxembourg and Taxes (in constant 2015 US$) of Pakistan?
Your answer should be compact. 9.88e+08. In the year 2008, what is the difference between the Taxes (in constant 2015 US$) of Luxembourg and Taxes (in constant 2015 US$) of Tuvalu?
Make the answer very short. 5.50e+09. In the year 2008, what is the difference between the Taxes (in constant 2015 US$) of Pakistan and Taxes (in constant 2015 US$) of Tuvalu?
Ensure brevity in your answer.  4.51e+09. In the year 2009, what is the difference between the Taxes (in constant 2015 US$) of Kazakhstan and Taxes (in constant 2015 US$) of Luxembourg?
Provide a short and direct response. 2.10e+08. In the year 2009, what is the difference between the Taxes (in constant 2015 US$) of Kazakhstan and Taxes (in constant 2015 US$) of Pakistan?
Provide a succinct answer. -3.07e+09. In the year 2009, what is the difference between the Taxes (in constant 2015 US$) in Kazakhstan and Taxes (in constant 2015 US$) in Tuvalu?
Make the answer very short. 5.30e+09. In the year 2009, what is the difference between the Taxes (in constant 2015 US$) of Luxembourg and Taxes (in constant 2015 US$) of Pakistan?
Your response must be concise. -3.28e+09. In the year 2009, what is the difference between the Taxes (in constant 2015 US$) of Luxembourg and Taxes (in constant 2015 US$) of Tuvalu?
Provide a succinct answer. 5.09e+09. In the year 2009, what is the difference between the Taxes (in constant 2015 US$) of Pakistan and Taxes (in constant 2015 US$) of Tuvalu?
Your response must be concise. 8.37e+09. In the year 2010, what is the difference between the Taxes (in constant 2015 US$) of Kazakhstan and Taxes (in constant 2015 US$) of Luxembourg?
Provide a succinct answer. 2.83e+09. In the year 2010, what is the difference between the Taxes (in constant 2015 US$) of Kazakhstan and Taxes (in constant 2015 US$) of Pakistan?
Your answer should be compact. 5.36e+08. In the year 2010, what is the difference between the Taxes (in constant 2015 US$) in Kazakhstan and Taxes (in constant 2015 US$) in Tuvalu?
Keep it short and to the point. 7.91e+09. In the year 2010, what is the difference between the Taxes (in constant 2015 US$) in Luxembourg and Taxes (in constant 2015 US$) in Pakistan?
Provide a short and direct response. -2.29e+09. In the year 2010, what is the difference between the Taxes (in constant 2015 US$) of Luxembourg and Taxes (in constant 2015 US$) of Tuvalu?
Keep it short and to the point. 5.09e+09. In the year 2010, what is the difference between the Taxes (in constant 2015 US$) of Pakistan and Taxes (in constant 2015 US$) of Tuvalu?
Provide a short and direct response. 7.38e+09. In the year 2011, what is the difference between the Taxes (in constant 2015 US$) in Kazakhstan and Taxes (in constant 2015 US$) in Luxembourg?
Make the answer very short. 6.60e+09. In the year 2011, what is the difference between the Taxes (in constant 2015 US$) of Kazakhstan and Taxes (in constant 2015 US$) of Pakistan?
Your response must be concise. 5.09e+09. In the year 2011, what is the difference between the Taxes (in constant 2015 US$) in Kazakhstan and Taxes (in constant 2015 US$) in Tuvalu?
Your response must be concise. 1.24e+1. In the year 2011, what is the difference between the Taxes (in constant 2015 US$) of Luxembourg and Taxes (in constant 2015 US$) of Pakistan?
Make the answer very short. -1.50e+09. In the year 2011, what is the difference between the Taxes (in constant 2015 US$) in Luxembourg and Taxes (in constant 2015 US$) in Tuvalu?
Your answer should be very brief. 5.85e+09. In the year 2011, what is the difference between the Taxes (in constant 2015 US$) of Pakistan and Taxes (in constant 2015 US$) of Tuvalu?
Make the answer very short. 7.35e+09. What is the ratio of the Taxes (in constant 2015 US$) of Kazakhstan in 2004 to that in 2005?
Your answer should be compact. 0.74. What is the ratio of the Taxes (in constant 2015 US$) of Luxembourg in 2004 to that in 2005?
Provide a succinct answer. 0.92. What is the ratio of the Taxes (in constant 2015 US$) of Pakistan in 2004 to that in 2005?
Provide a succinct answer. 1.07. What is the ratio of the Taxes (in constant 2015 US$) of Tuvalu in 2004 to that in 2005?
Your answer should be compact. 0.99. What is the ratio of the Taxes (in constant 2015 US$) of Kazakhstan in 2004 to that in 2006?
Provide a succinct answer. 0.49. What is the ratio of the Taxes (in constant 2015 US$) of Luxembourg in 2004 to that in 2006?
Your response must be concise. 0.88. What is the ratio of the Taxes (in constant 2015 US$) of Pakistan in 2004 to that in 2006?
Offer a very short reply. 0.81. What is the ratio of the Taxes (in constant 2015 US$) of Tuvalu in 2004 to that in 2006?
Ensure brevity in your answer.  1.07. What is the ratio of the Taxes (in constant 2015 US$) of Kazakhstan in 2004 to that in 2007?
Offer a very short reply. 0.35. What is the ratio of the Taxes (in constant 2015 US$) in Luxembourg in 2004 to that in 2007?
Provide a succinct answer. 0.72. What is the ratio of the Taxes (in constant 2015 US$) of Pakistan in 2004 to that in 2007?
Provide a short and direct response. 0.82. What is the ratio of the Taxes (in constant 2015 US$) in Tuvalu in 2004 to that in 2007?
Your answer should be compact. 0.91. What is the ratio of the Taxes (in constant 2015 US$) of Kazakhstan in 2004 to that in 2008?
Give a very brief answer. 0.28. What is the ratio of the Taxes (in constant 2015 US$) in Luxembourg in 2004 to that in 2008?
Keep it short and to the point. 0.67. What is the ratio of the Taxes (in constant 2015 US$) of Pakistan in 2004 to that in 2008?
Your answer should be very brief. 1.5. What is the ratio of the Taxes (in constant 2015 US$) of Tuvalu in 2004 to that in 2008?
Your answer should be compact. 0.8. What is the ratio of the Taxes (in constant 2015 US$) in Kazakhstan in 2004 to that in 2009?
Provide a short and direct response. 0.49. What is the ratio of the Taxes (in constant 2015 US$) in Luxembourg in 2004 to that in 2009?
Ensure brevity in your answer.  0.72. What is the ratio of the Taxes (in constant 2015 US$) of Pakistan in 2004 to that in 2009?
Your response must be concise. 0.81. What is the ratio of the Taxes (in constant 2015 US$) in Tuvalu in 2004 to that in 2009?
Make the answer very short. 1. What is the ratio of the Taxes (in constant 2015 US$) of Kazakhstan in 2004 to that in 2010?
Provide a succinct answer. 0.33. What is the ratio of the Taxes (in constant 2015 US$) of Luxembourg in 2004 to that in 2010?
Your answer should be very brief. 0.72. What is the ratio of the Taxes (in constant 2015 US$) of Pakistan in 2004 to that in 2010?
Your response must be concise. 0.92. What is the ratio of the Taxes (in constant 2015 US$) of Tuvalu in 2004 to that in 2010?
Make the answer very short. 0.98. What is the ratio of the Taxes (in constant 2015 US$) in Kazakhstan in 2004 to that in 2011?
Offer a very short reply. 0.21. What is the ratio of the Taxes (in constant 2015 US$) in Luxembourg in 2004 to that in 2011?
Your response must be concise. 0.63. What is the ratio of the Taxes (in constant 2015 US$) of Pakistan in 2004 to that in 2011?
Your answer should be very brief. 0.92. What is the ratio of the Taxes (in constant 2015 US$) in Tuvalu in 2004 to that in 2011?
Give a very brief answer. 0.81. What is the ratio of the Taxes (in constant 2015 US$) in Kazakhstan in 2005 to that in 2006?
Offer a terse response. 0.67. What is the ratio of the Taxes (in constant 2015 US$) of Luxembourg in 2005 to that in 2006?
Your response must be concise. 0.96. What is the ratio of the Taxes (in constant 2015 US$) in Pakistan in 2005 to that in 2006?
Offer a very short reply. 0.76. What is the ratio of the Taxes (in constant 2015 US$) in Tuvalu in 2005 to that in 2006?
Keep it short and to the point. 1.08. What is the ratio of the Taxes (in constant 2015 US$) of Kazakhstan in 2005 to that in 2007?
Make the answer very short. 0.47. What is the ratio of the Taxes (in constant 2015 US$) of Luxembourg in 2005 to that in 2007?
Offer a very short reply. 0.78. What is the ratio of the Taxes (in constant 2015 US$) of Pakistan in 2005 to that in 2007?
Make the answer very short. 0.76. What is the ratio of the Taxes (in constant 2015 US$) of Tuvalu in 2005 to that in 2007?
Your answer should be compact. 0.91. What is the ratio of the Taxes (in constant 2015 US$) in Kazakhstan in 2005 to that in 2008?
Offer a terse response. 0.38. What is the ratio of the Taxes (in constant 2015 US$) in Luxembourg in 2005 to that in 2008?
Make the answer very short. 0.73. What is the ratio of the Taxes (in constant 2015 US$) in Pakistan in 2005 to that in 2008?
Ensure brevity in your answer.  1.41. What is the ratio of the Taxes (in constant 2015 US$) of Tuvalu in 2005 to that in 2008?
Provide a succinct answer. 0.8. What is the ratio of the Taxes (in constant 2015 US$) in Kazakhstan in 2005 to that in 2009?
Your answer should be very brief. 0.66. What is the ratio of the Taxes (in constant 2015 US$) in Luxembourg in 2005 to that in 2009?
Your answer should be very brief. 0.78. What is the ratio of the Taxes (in constant 2015 US$) in Pakistan in 2005 to that in 2009?
Your response must be concise. 0.76. What is the ratio of the Taxes (in constant 2015 US$) in Tuvalu in 2005 to that in 2009?
Ensure brevity in your answer.  1.01. What is the ratio of the Taxes (in constant 2015 US$) of Kazakhstan in 2005 to that in 2010?
Your answer should be compact. 0.44. What is the ratio of the Taxes (in constant 2015 US$) of Luxembourg in 2005 to that in 2010?
Make the answer very short. 0.79. What is the ratio of the Taxes (in constant 2015 US$) of Pakistan in 2005 to that in 2010?
Give a very brief answer. 0.86. What is the ratio of the Taxes (in constant 2015 US$) of Kazakhstan in 2005 to that in 2011?
Offer a terse response. 0.28. What is the ratio of the Taxes (in constant 2015 US$) in Luxembourg in 2005 to that in 2011?
Your response must be concise. 0.68. What is the ratio of the Taxes (in constant 2015 US$) of Pakistan in 2005 to that in 2011?
Ensure brevity in your answer.  0.86. What is the ratio of the Taxes (in constant 2015 US$) in Tuvalu in 2005 to that in 2011?
Keep it short and to the point. 0.81. What is the ratio of the Taxes (in constant 2015 US$) of Kazakhstan in 2006 to that in 2007?
Provide a succinct answer. 0.7. What is the ratio of the Taxes (in constant 2015 US$) of Luxembourg in 2006 to that in 2007?
Your answer should be very brief. 0.81. What is the ratio of the Taxes (in constant 2015 US$) in Pakistan in 2006 to that in 2007?
Provide a short and direct response. 1.01. What is the ratio of the Taxes (in constant 2015 US$) of Tuvalu in 2006 to that in 2007?
Provide a short and direct response. 0.85. What is the ratio of the Taxes (in constant 2015 US$) in Kazakhstan in 2006 to that in 2008?
Offer a very short reply. 0.56. What is the ratio of the Taxes (in constant 2015 US$) of Luxembourg in 2006 to that in 2008?
Give a very brief answer. 0.76. What is the ratio of the Taxes (in constant 2015 US$) in Pakistan in 2006 to that in 2008?
Your answer should be very brief. 1.85. What is the ratio of the Taxes (in constant 2015 US$) in Tuvalu in 2006 to that in 2008?
Give a very brief answer. 0.74. What is the ratio of the Taxes (in constant 2015 US$) in Luxembourg in 2006 to that in 2009?
Make the answer very short. 0.82. What is the ratio of the Taxes (in constant 2015 US$) in Pakistan in 2006 to that in 2009?
Offer a very short reply. 1. What is the ratio of the Taxes (in constant 2015 US$) of Tuvalu in 2006 to that in 2009?
Make the answer very short. 0.93. What is the ratio of the Taxes (in constant 2015 US$) of Kazakhstan in 2006 to that in 2010?
Provide a short and direct response. 0.67. What is the ratio of the Taxes (in constant 2015 US$) in Luxembourg in 2006 to that in 2010?
Offer a very short reply. 0.82. What is the ratio of the Taxes (in constant 2015 US$) of Pakistan in 2006 to that in 2010?
Ensure brevity in your answer.  1.13. What is the ratio of the Taxes (in constant 2015 US$) of Tuvalu in 2006 to that in 2010?
Your answer should be compact. 0.91. What is the ratio of the Taxes (in constant 2015 US$) of Kazakhstan in 2006 to that in 2011?
Provide a succinct answer. 0.42. What is the ratio of the Taxes (in constant 2015 US$) in Luxembourg in 2006 to that in 2011?
Your response must be concise. 0.71. What is the ratio of the Taxes (in constant 2015 US$) of Pakistan in 2006 to that in 2011?
Offer a terse response. 1.14. What is the ratio of the Taxes (in constant 2015 US$) of Tuvalu in 2006 to that in 2011?
Provide a succinct answer. 0.75. What is the ratio of the Taxes (in constant 2015 US$) in Kazakhstan in 2007 to that in 2008?
Offer a very short reply. 0.8. What is the ratio of the Taxes (in constant 2015 US$) in Luxembourg in 2007 to that in 2008?
Provide a short and direct response. 0.93. What is the ratio of the Taxes (in constant 2015 US$) of Pakistan in 2007 to that in 2008?
Make the answer very short. 1.84. What is the ratio of the Taxes (in constant 2015 US$) of Tuvalu in 2007 to that in 2008?
Your answer should be compact. 0.88. What is the ratio of the Taxes (in constant 2015 US$) in Kazakhstan in 2007 to that in 2009?
Provide a short and direct response. 1.41. What is the ratio of the Taxes (in constant 2015 US$) of Luxembourg in 2007 to that in 2009?
Your answer should be very brief. 1. What is the ratio of the Taxes (in constant 2015 US$) in Tuvalu in 2007 to that in 2009?
Offer a terse response. 1.1. What is the ratio of the Taxes (in constant 2015 US$) in Kazakhstan in 2007 to that in 2010?
Your response must be concise. 0.95. What is the ratio of the Taxes (in constant 2015 US$) in Pakistan in 2007 to that in 2010?
Ensure brevity in your answer.  1.13. What is the ratio of the Taxes (in constant 2015 US$) in Tuvalu in 2007 to that in 2010?
Give a very brief answer. 1.08. What is the ratio of the Taxes (in constant 2015 US$) of Kazakhstan in 2007 to that in 2011?
Make the answer very short. 0.6. What is the ratio of the Taxes (in constant 2015 US$) in Luxembourg in 2007 to that in 2011?
Your answer should be very brief. 0.87. What is the ratio of the Taxes (in constant 2015 US$) in Pakistan in 2007 to that in 2011?
Keep it short and to the point. 1.13. What is the ratio of the Taxes (in constant 2015 US$) in Tuvalu in 2007 to that in 2011?
Provide a short and direct response. 0.89. What is the ratio of the Taxes (in constant 2015 US$) in Kazakhstan in 2008 to that in 2009?
Offer a terse response. 1.76. What is the ratio of the Taxes (in constant 2015 US$) in Luxembourg in 2008 to that in 2009?
Offer a terse response. 1.08. What is the ratio of the Taxes (in constant 2015 US$) of Pakistan in 2008 to that in 2009?
Provide a succinct answer. 0.54. What is the ratio of the Taxes (in constant 2015 US$) in Tuvalu in 2008 to that in 2009?
Offer a very short reply. 1.25. What is the ratio of the Taxes (in constant 2015 US$) of Kazakhstan in 2008 to that in 2010?
Keep it short and to the point. 1.18. What is the ratio of the Taxes (in constant 2015 US$) in Luxembourg in 2008 to that in 2010?
Your answer should be very brief. 1.08. What is the ratio of the Taxes (in constant 2015 US$) of Pakistan in 2008 to that in 2010?
Make the answer very short. 0.61. What is the ratio of the Taxes (in constant 2015 US$) in Tuvalu in 2008 to that in 2010?
Ensure brevity in your answer.  1.23. What is the ratio of the Taxes (in constant 2015 US$) of Kazakhstan in 2008 to that in 2011?
Provide a short and direct response. 0.75. What is the ratio of the Taxes (in constant 2015 US$) of Luxembourg in 2008 to that in 2011?
Provide a short and direct response. 0.94. What is the ratio of the Taxes (in constant 2015 US$) of Pakistan in 2008 to that in 2011?
Your response must be concise. 0.61. What is the ratio of the Taxes (in constant 2015 US$) of Tuvalu in 2008 to that in 2011?
Keep it short and to the point. 1.01. What is the ratio of the Taxes (in constant 2015 US$) of Kazakhstan in 2009 to that in 2010?
Give a very brief answer. 0.67. What is the ratio of the Taxes (in constant 2015 US$) of Luxembourg in 2009 to that in 2010?
Your response must be concise. 1. What is the ratio of the Taxes (in constant 2015 US$) of Pakistan in 2009 to that in 2010?
Make the answer very short. 1.13. What is the ratio of the Taxes (in constant 2015 US$) in Tuvalu in 2009 to that in 2010?
Offer a terse response. 0.98. What is the ratio of the Taxes (in constant 2015 US$) of Kazakhstan in 2009 to that in 2011?
Your answer should be compact. 0.43. What is the ratio of the Taxes (in constant 2015 US$) in Luxembourg in 2009 to that in 2011?
Provide a short and direct response. 0.87. What is the ratio of the Taxes (in constant 2015 US$) in Pakistan in 2009 to that in 2011?
Keep it short and to the point. 1.14. What is the ratio of the Taxes (in constant 2015 US$) of Tuvalu in 2009 to that in 2011?
Make the answer very short. 0.81. What is the ratio of the Taxes (in constant 2015 US$) of Kazakhstan in 2010 to that in 2011?
Provide a succinct answer. 0.64. What is the ratio of the Taxes (in constant 2015 US$) of Luxembourg in 2010 to that in 2011?
Offer a terse response. 0.87. What is the ratio of the Taxes (in constant 2015 US$) in Tuvalu in 2010 to that in 2011?
Your answer should be very brief. 0.83. What is the difference between the highest and the second highest Taxes (in constant 2015 US$) in Kazakhstan?
Your answer should be very brief. 3.09e+09. What is the difference between the highest and the second highest Taxes (in constant 2015 US$) of Luxembourg?
Make the answer very short. 3.46e+08. What is the difference between the highest and the second highest Taxes (in constant 2015 US$) of Pakistan?
Offer a terse response. 1.55e+07. What is the difference between the highest and the second highest Taxes (in constant 2015 US$) of Tuvalu?
Make the answer very short. 3.36e+04. What is the difference between the highest and the lowest Taxes (in constant 2015 US$) of Kazakhstan?
Give a very brief answer. 9.85e+09. What is the difference between the highest and the lowest Taxes (in constant 2015 US$) in Luxembourg?
Ensure brevity in your answer.  2.18e+09. What is the difference between the highest and the lowest Taxes (in constant 2015 US$) in Pakistan?
Ensure brevity in your answer.  3.86e+09. What is the difference between the highest and the lowest Taxes (in constant 2015 US$) of Tuvalu?
Provide a short and direct response. 6.83e+05. 